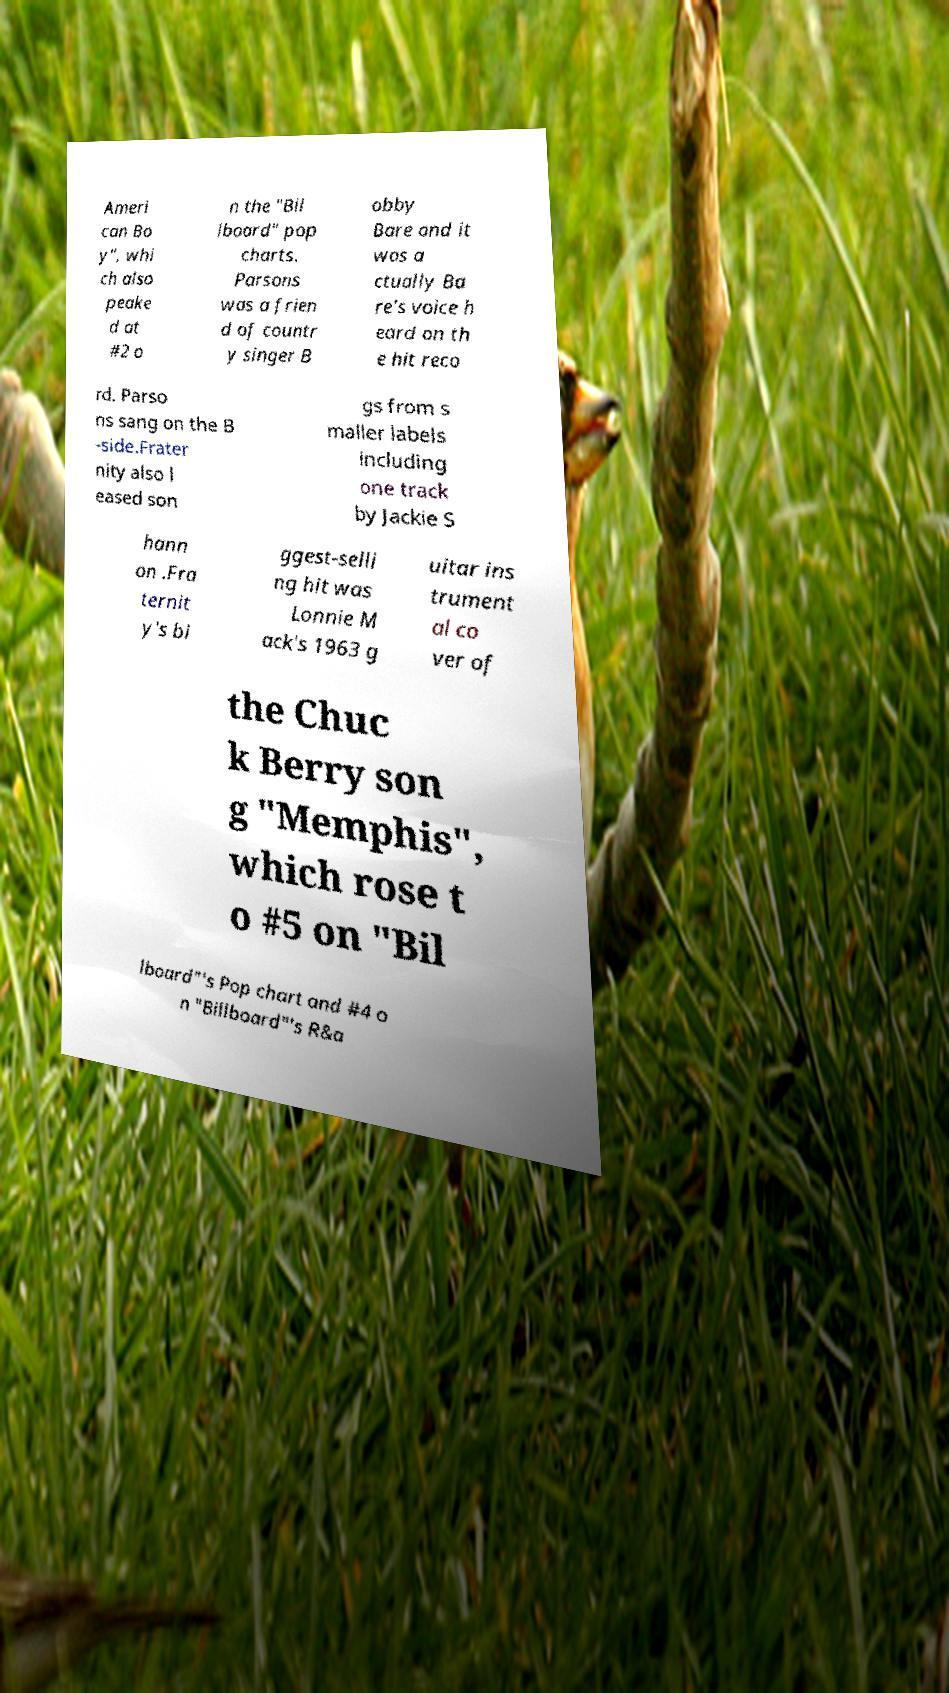Can you accurately transcribe the text from the provided image for me? Ameri can Bo y", whi ch also peake d at #2 o n the "Bil lboard" pop charts. Parsons was a frien d of countr y singer B obby Bare and it was a ctually Ba re's voice h eard on th e hit reco rd. Parso ns sang on the B -side.Frater nity also l eased son gs from s maller labels including one track by Jackie S hann on .Fra ternit y's bi ggest-selli ng hit was Lonnie M ack's 1963 g uitar ins trument al co ver of the Chuc k Berry son g "Memphis", which rose t o #5 on "Bil lboard"′s Pop chart and #4 o n "Billboard"′s R&a 